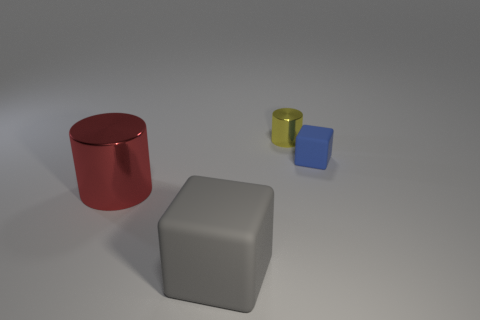Add 4 big red metal objects. How many objects exist? 8 Add 4 large red objects. How many large red objects exist? 5 Subtract 0 purple cubes. How many objects are left? 4 Subtract all small yellow things. Subtract all large gray rubber spheres. How many objects are left? 3 Add 1 large gray rubber cubes. How many large gray rubber cubes are left? 2 